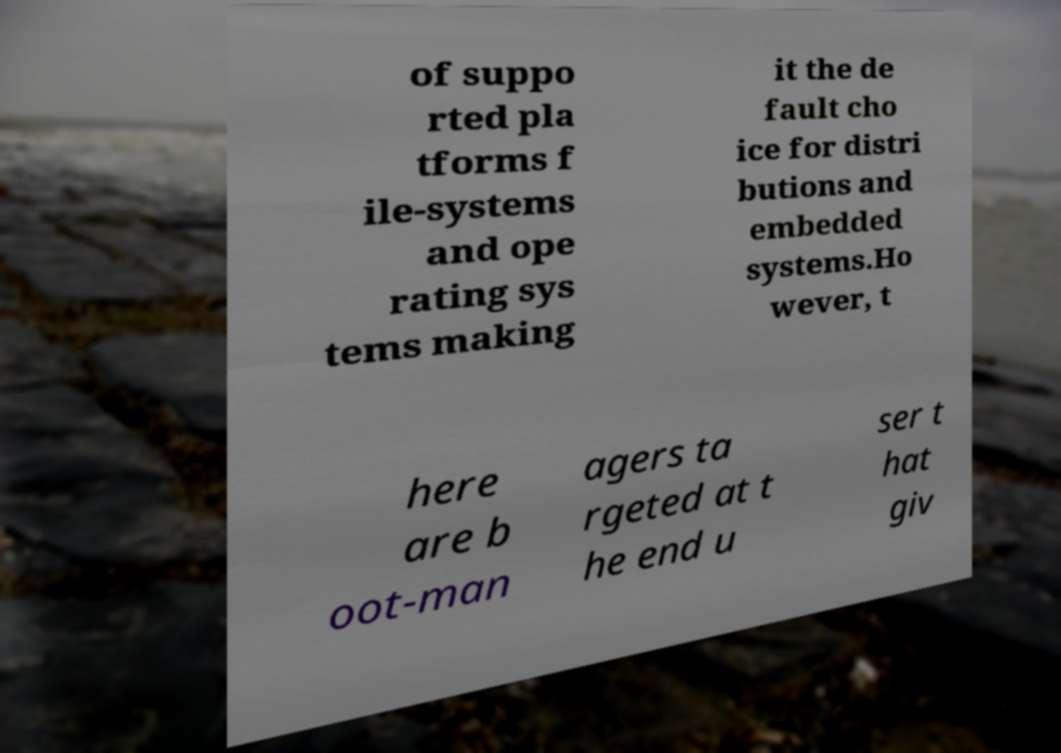Could you assist in decoding the text presented in this image and type it out clearly? of suppo rted pla tforms f ile-systems and ope rating sys tems making it the de fault cho ice for distri butions and embedded systems.Ho wever, t here are b oot-man agers ta rgeted at t he end u ser t hat giv 